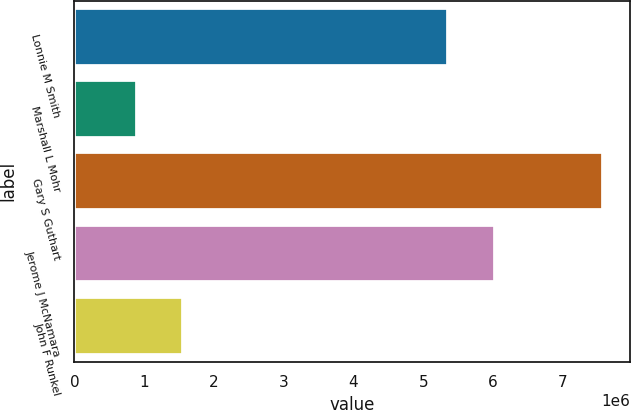Convert chart to OTSL. <chart><loc_0><loc_0><loc_500><loc_500><bar_chart><fcel>Lonnie M Smith<fcel>Marshall L Mohr<fcel>Gary S Guthart<fcel>Jerome J McNamara<fcel>John F Runkel<nl><fcel>5.3538e+06<fcel>893040<fcel>7.58412e+06<fcel>6.0229e+06<fcel>1.56215e+06<nl></chart> 